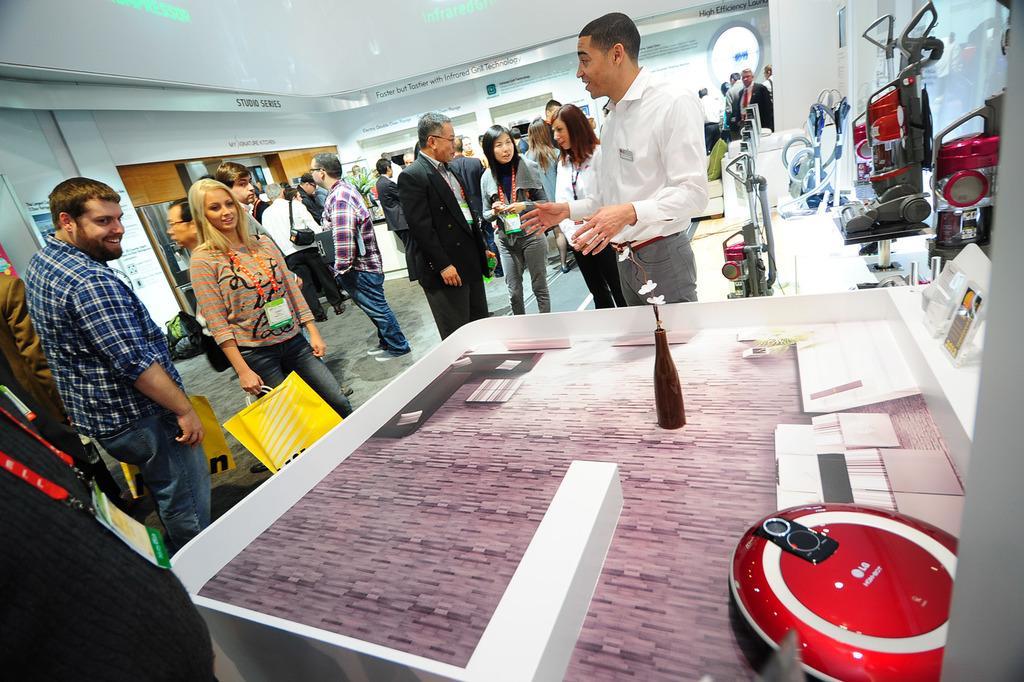Please provide a concise description of this image. In this image we can see many people. Some are wearing tags. Some are holding covers. There is a platform. On that there is a bottle with flowers and some other device. On the right side we can see many devices. In the back there is a wall. On the wall something is written. 